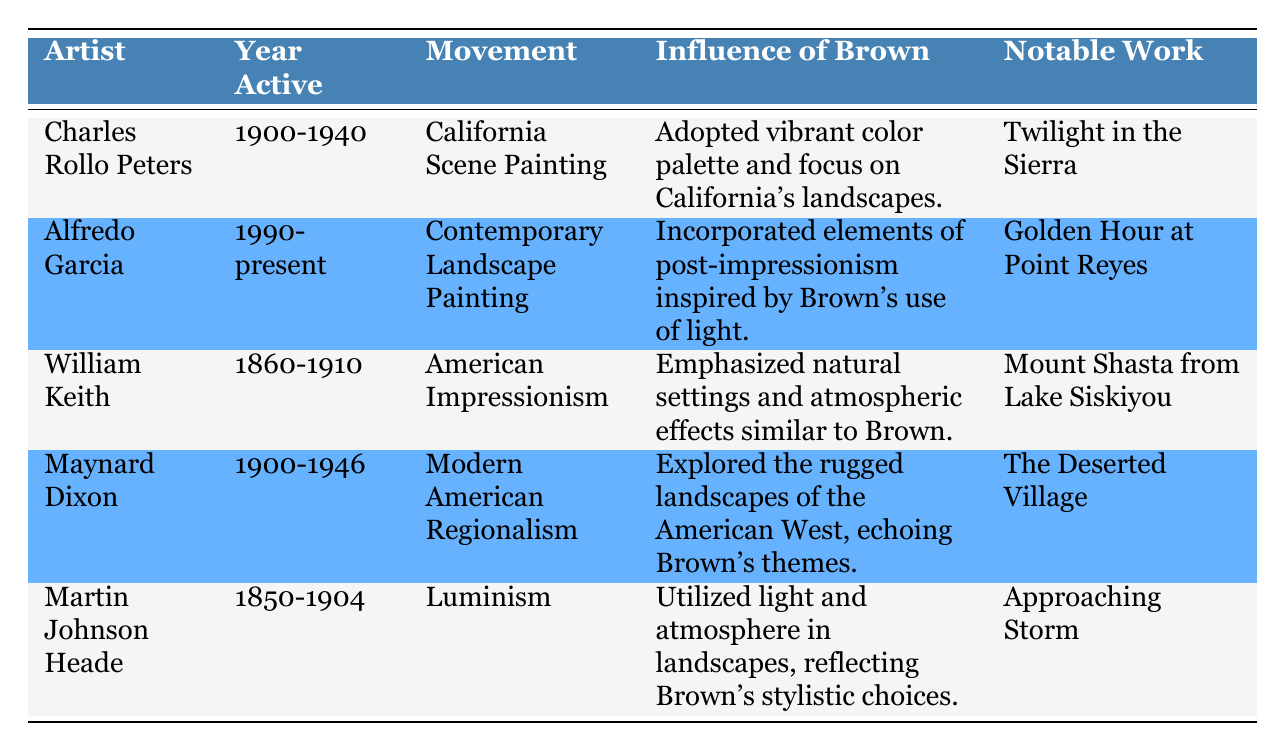What is the notable work of Charles Rollo Peters? According to the table, the notable work listed for Charles Rollo Peters is "Twilight in the Sierra."
Answer: Twilight in the Sierra Which artist was active during the 1990s and beyond? The table indicates that Alfredo Garcia is the artist who has been active from 1990 to the present.
Answer: Alfredo Garcia How many artists listed were active in the 1900s? There are three artists who were active in the 1900s: Charles Rollo Peters, Maynard Dixon, and Martin Johnson Heade. This can be counted directly from the year active column.
Answer: 3 Did William Keith emphasize natural settings in his work? Yes, the influence of Brown on William Keith is noted as having emphasized natural settings and atmospheric effects, which indicates that he did explore those themes.
Answer: Yes Which movement is associated with Martin Johnson Heade? The table shows that Martin Johnson Heade is associated with the Luminism movement.
Answer: Luminism What is the average year range of activity for the artists listed? The year ranges are: Charles Rollo Peters (1900-1940), Alfredo Garcia (1990-present), William Keith (1860-1910), Maynard Dixon (1900-1946), and Martin Johnson Heade (1850-1904). First, we determine the respective year ranges (1900, 1940; 1990, -; 1860, 1910; 1900, 1946; 1850, 1904). Conclusively, the average of the starting years (1900 + 1990 + 1860 + 1900 + 1850) / 5 = 1860 and the average of the ending years (1940 + current year + 1910 + 1946 + 1904) divided by the total number will yield a rough evaluation focusing on early to mid-20th century landscape creation.
Answer: Approximately 1900 What influence did Maynard Dixon take from Grafton Tyler Brown? The influence noted for Maynard Dixon indicates he explored the rugged landscapes of the American West, which echoes the themes present in Brown's works.
Answer: Explored rugged landscapes Which two movements were influenced by Grafton Tyler Brown's use of light? The table highlights that both Martin Johnson Heade (Luminism) and Alfredo Garcia (Contemporary Landscape Painting) show influence from Brown's use of light, suggesting both movements showed this characteristic.
Answer: Luminism and Contemporary Landscape Painting 